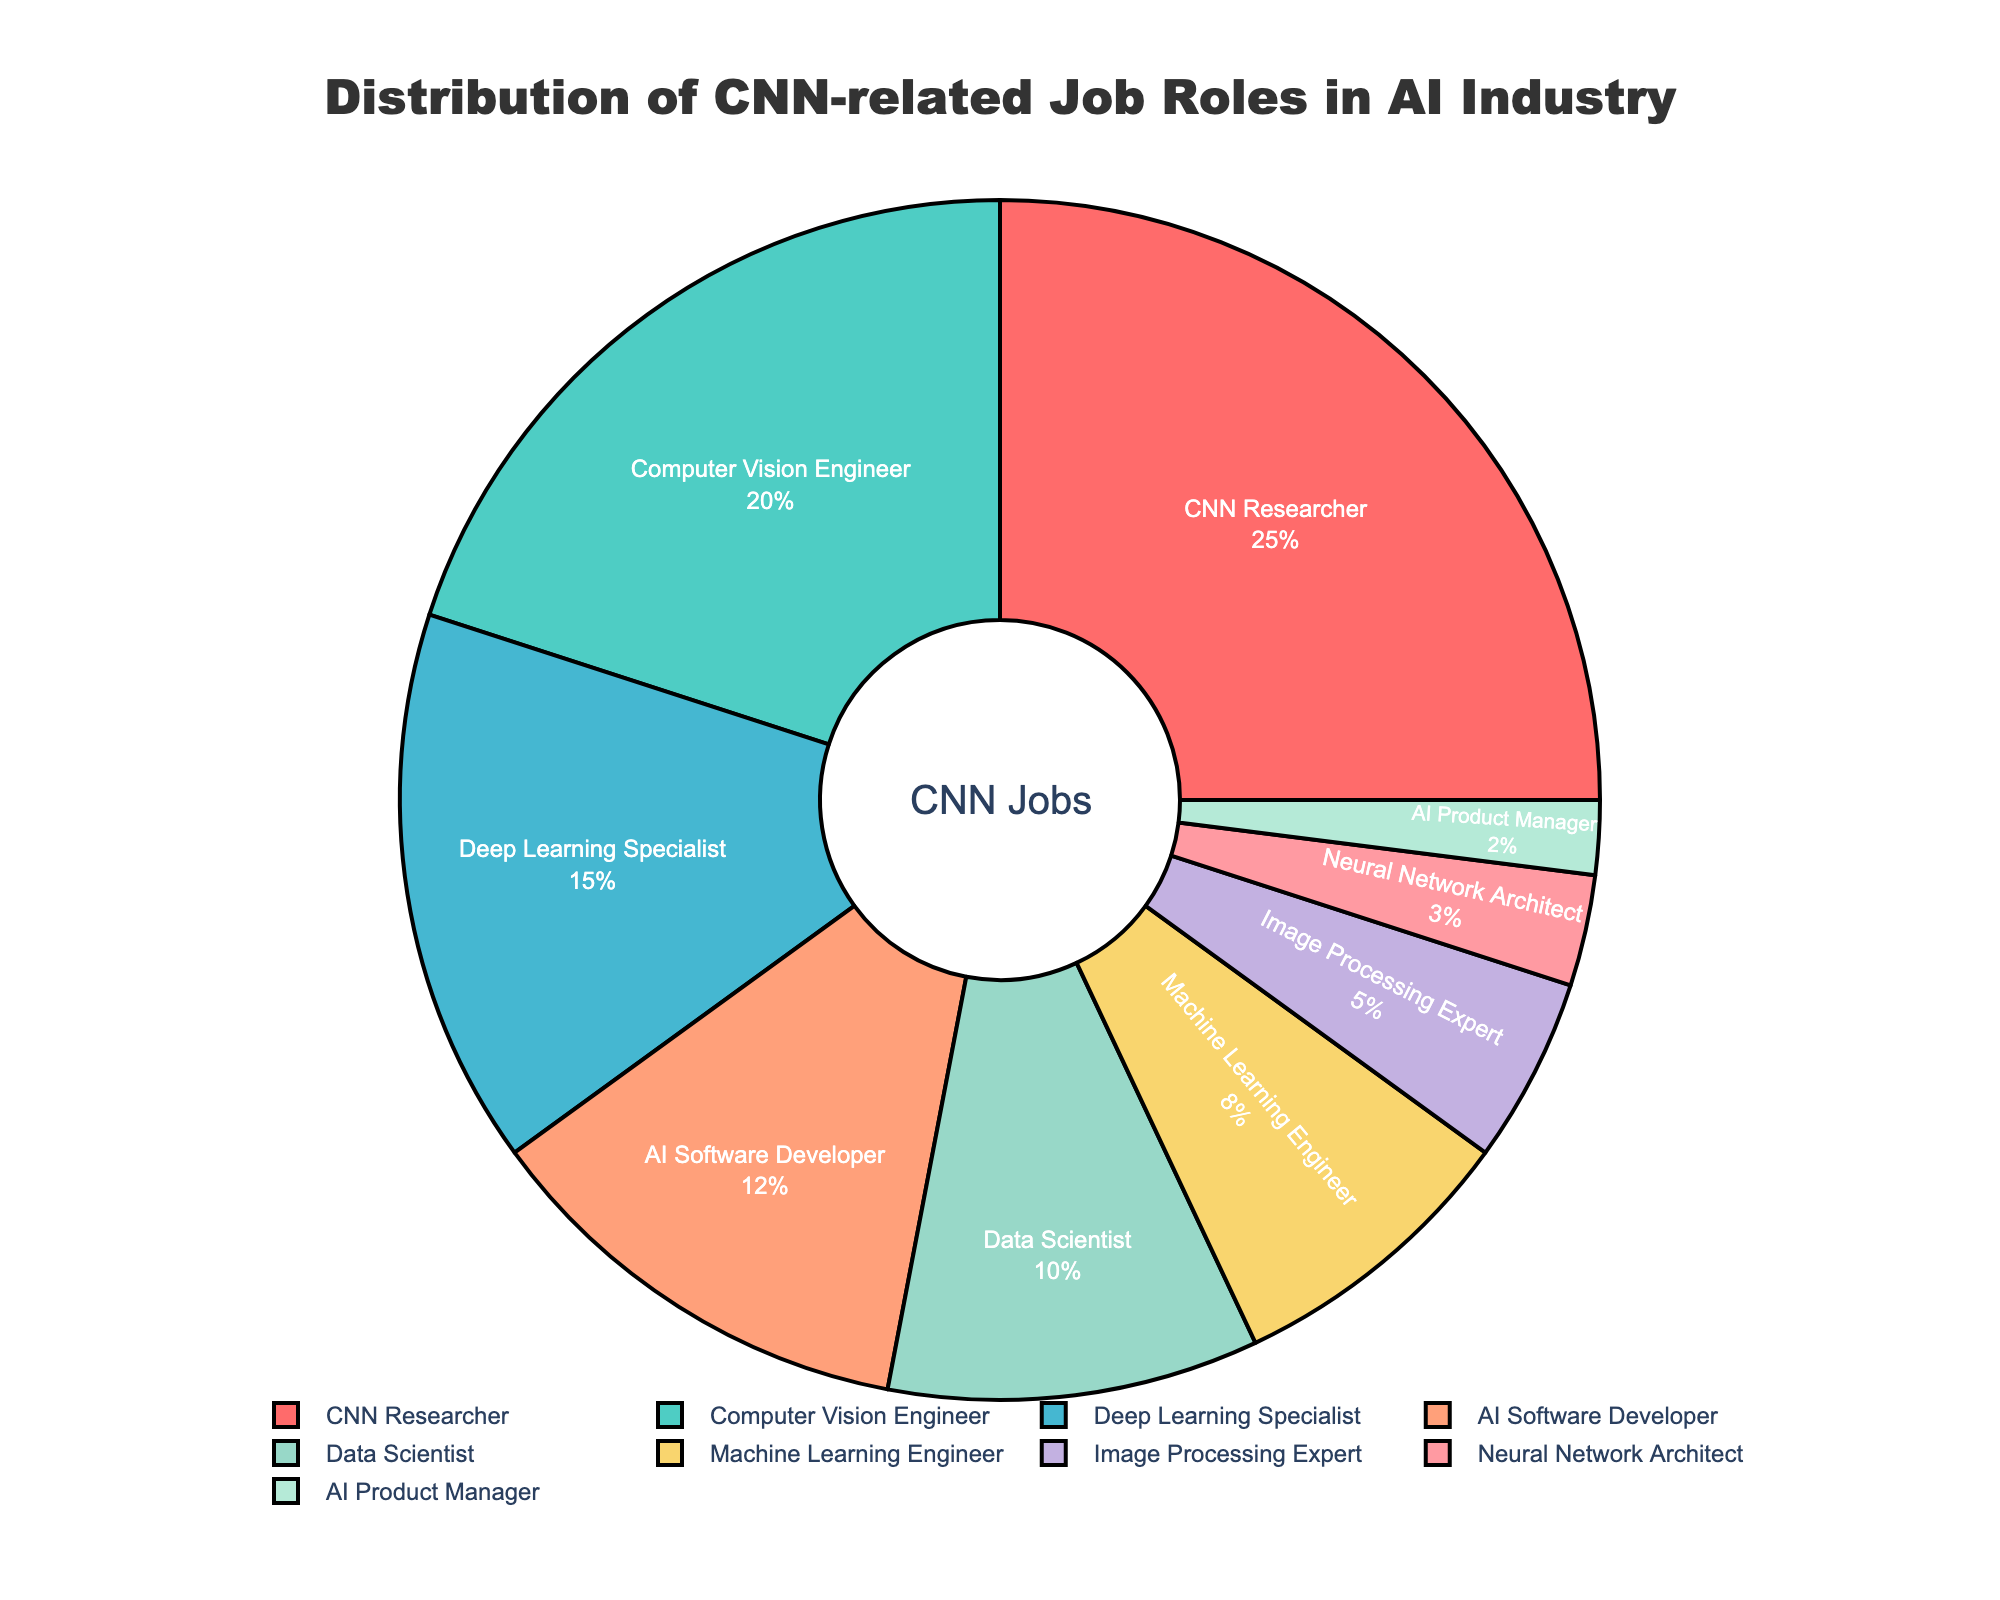What percentage of job roles are 'Data Scientist' and 'Machine Learning Engineer' combined? 'Data Scientist' has 10% and 'Machine Learning Engineer' has 8%. Combined, it is 10% + 8% = 18%.
Answer: 18% Which job role has the second highest percentage? From the pie chart, the job role with the highest percentage is 'CNN Researcher' (25%). The job role with the second highest percentage is 'Computer Vision Engineer' (20%).
Answer: Computer Vision Engineer Which job role is represented by the color red? The job role with the highest percentage, 'CNN Researcher' (25%), is represented by the color red.
Answer: CNN Researcher How does the percentage of 'Deep Learning Specialist' compare to 'AI Software Developer'? 'Deep Learning Specialist' has 15%, while 'AI Software Developer' has 12%. 15% is greater than 12%, so 'Deep Learning Specialist' has a higher percentage.
Answer: Greater What is the smallest percentage represented in the chart and which job role does it correspond to? The smallest percentage in the chart is 2%, and it corresponds to the 'AI Product Manager' job role.
Answer: 2% What is the difference in percentage between 'CNN Researcher' and 'Neural Network Architect'? 'CNN Researcher' has 25% and 'Neural Network Architect' has 3%. The difference is 25% - 3% = 22%.
Answer: 22% What percentage do 'Image Processing Expert' and 'Neural Network Architect' together contribute to the distribution? 'Image Processing Expert' is 5% and 'Neural Network Architect' is 3%. Together, they contribute 5% + 3% = 8%.
Answer: 8% What percentage does the central hole in the pie chart represent? The central hole represents 30% of the total pie chart, as denoted by 'hole=.3' in the configuration of the pie chart.
Answer: 30% Rank the percentages of 'Data Scientist', 'AI Product Manager', and 'Deep Learning Specialist' in ascending order. 'AI Product Manager' is 2%, 'Data Scientist' is 10%, and 'Deep Learning Specialist' is 15%. In ascending order, they are 2%, 10%, 15%.
Answer: 2%, 10%, 15% Considering the three job roles with the least percentage, what is their total combined percentage? The job roles with the least percentage are 'AI Product Manager' (2%), 'Neural Network Architect' (3%), and 'Image Processing Expert' (5%). Their combined percentage is 2% + 3% + 5% = 10%.
Answer: 10% 